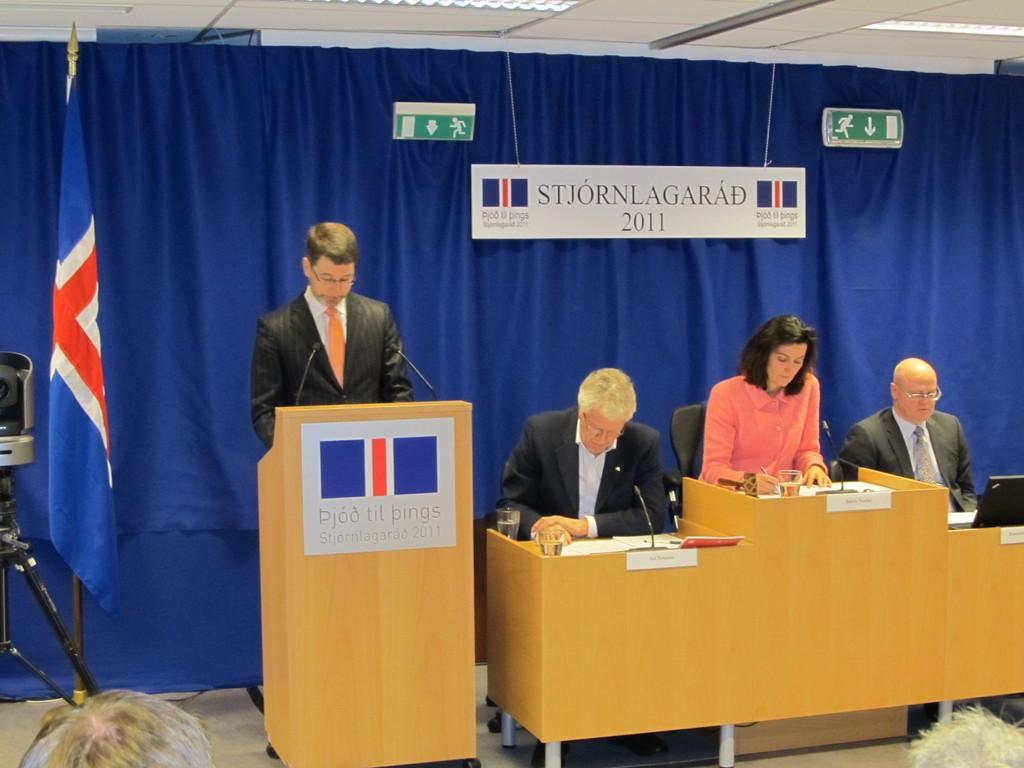<image>
Summarize the visual content of the image. Three people are on a stage, at a desk, underneath a banner that says Stjornlagarad 2011 as another mas appears to be speaking at a podium. 